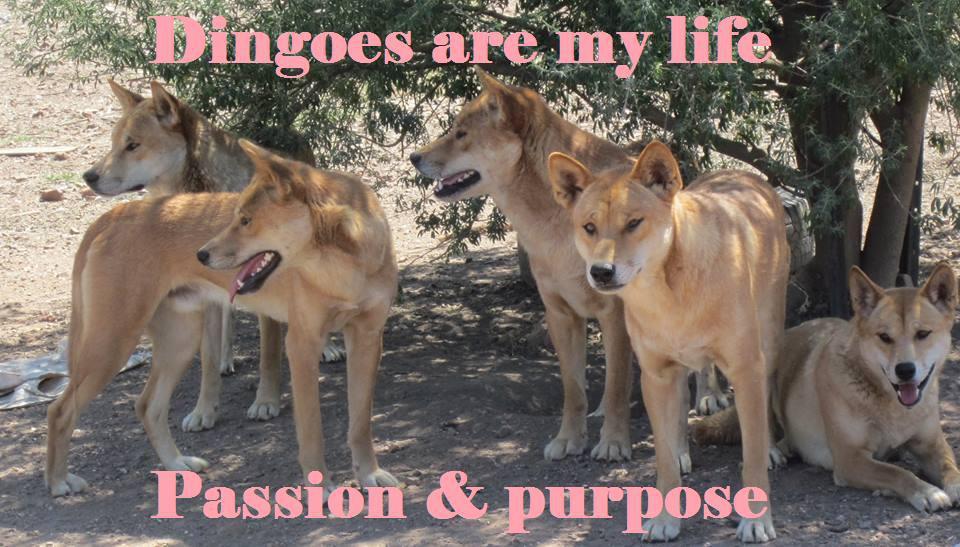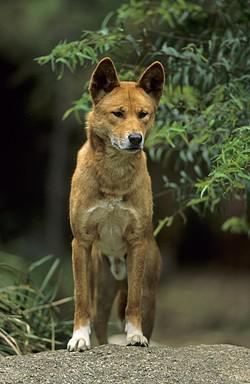The first image is the image on the left, the second image is the image on the right. Given the left and right images, does the statement "An image includes a dog sleeping on the ground." hold true? Answer yes or no. No. 